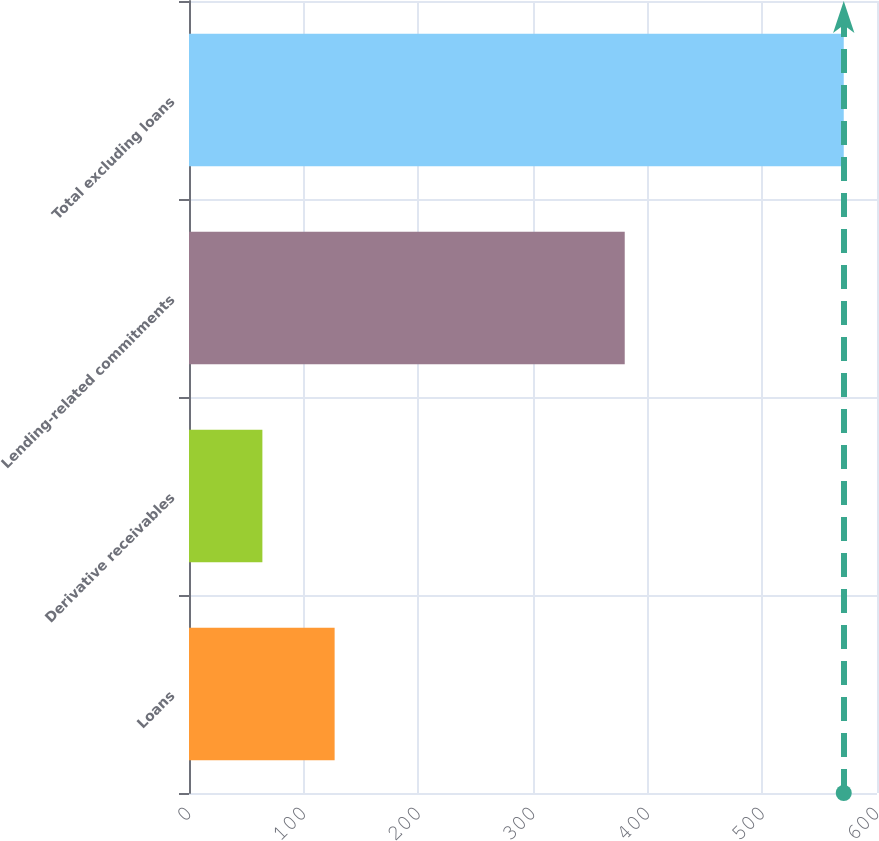Convert chart. <chart><loc_0><loc_0><loc_500><loc_500><bar_chart><fcel>Loans<fcel>Derivative receivables<fcel>Lending-related commitments<fcel>Total excluding loans<nl><fcel>127<fcel>64<fcel>380<fcel>571<nl></chart> 